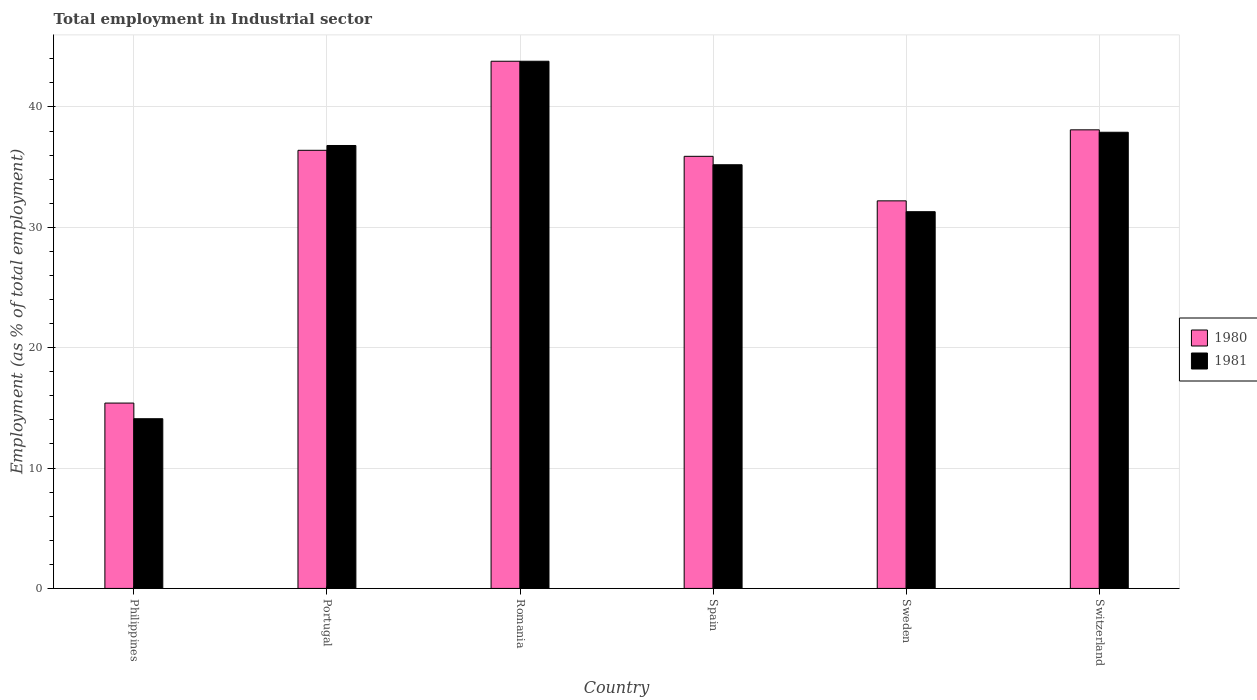How many groups of bars are there?
Offer a terse response. 6. Are the number of bars per tick equal to the number of legend labels?
Ensure brevity in your answer.  Yes. How many bars are there on the 3rd tick from the left?
Offer a terse response. 2. How many bars are there on the 1st tick from the right?
Provide a succinct answer. 2. What is the employment in industrial sector in 1981 in Philippines?
Ensure brevity in your answer.  14.1. Across all countries, what is the maximum employment in industrial sector in 1981?
Provide a succinct answer. 43.8. Across all countries, what is the minimum employment in industrial sector in 1980?
Ensure brevity in your answer.  15.4. In which country was the employment in industrial sector in 1980 maximum?
Ensure brevity in your answer.  Romania. What is the total employment in industrial sector in 1981 in the graph?
Give a very brief answer. 199.1. What is the difference between the employment in industrial sector in 1980 in Philippines and that in Sweden?
Offer a terse response. -16.8. What is the difference between the employment in industrial sector in 1980 in Switzerland and the employment in industrial sector in 1981 in Portugal?
Keep it short and to the point. 1.3. What is the average employment in industrial sector in 1981 per country?
Provide a succinct answer. 33.18. In how many countries, is the employment in industrial sector in 1981 greater than 34 %?
Offer a terse response. 4. What is the ratio of the employment in industrial sector in 1980 in Portugal to that in Switzerland?
Keep it short and to the point. 0.96. Is the employment in industrial sector in 1980 in Romania less than that in Spain?
Your response must be concise. No. Is the difference between the employment in industrial sector in 1980 in Philippines and Spain greater than the difference between the employment in industrial sector in 1981 in Philippines and Spain?
Your answer should be compact. Yes. What is the difference between the highest and the lowest employment in industrial sector in 1981?
Make the answer very short. 29.7. Is the sum of the employment in industrial sector in 1980 in Philippines and Spain greater than the maximum employment in industrial sector in 1981 across all countries?
Provide a succinct answer. Yes. What does the 2nd bar from the left in Philippines represents?
Keep it short and to the point. 1981. What does the 2nd bar from the right in Switzerland represents?
Your answer should be very brief. 1980. Are all the bars in the graph horizontal?
Give a very brief answer. No. What is the difference between two consecutive major ticks on the Y-axis?
Offer a terse response. 10. Are the values on the major ticks of Y-axis written in scientific E-notation?
Your answer should be very brief. No. Does the graph contain any zero values?
Offer a terse response. No. Does the graph contain grids?
Make the answer very short. Yes. Where does the legend appear in the graph?
Your response must be concise. Center right. How many legend labels are there?
Provide a short and direct response. 2. What is the title of the graph?
Offer a very short reply. Total employment in Industrial sector. What is the label or title of the Y-axis?
Make the answer very short. Employment (as % of total employment). What is the Employment (as % of total employment) in 1980 in Philippines?
Keep it short and to the point. 15.4. What is the Employment (as % of total employment) in 1981 in Philippines?
Provide a short and direct response. 14.1. What is the Employment (as % of total employment) in 1980 in Portugal?
Make the answer very short. 36.4. What is the Employment (as % of total employment) in 1981 in Portugal?
Your response must be concise. 36.8. What is the Employment (as % of total employment) in 1980 in Romania?
Offer a very short reply. 43.8. What is the Employment (as % of total employment) of 1981 in Romania?
Make the answer very short. 43.8. What is the Employment (as % of total employment) of 1980 in Spain?
Ensure brevity in your answer.  35.9. What is the Employment (as % of total employment) in 1981 in Spain?
Give a very brief answer. 35.2. What is the Employment (as % of total employment) of 1980 in Sweden?
Offer a very short reply. 32.2. What is the Employment (as % of total employment) of 1981 in Sweden?
Your answer should be compact. 31.3. What is the Employment (as % of total employment) in 1980 in Switzerland?
Keep it short and to the point. 38.1. What is the Employment (as % of total employment) of 1981 in Switzerland?
Your answer should be compact. 37.9. Across all countries, what is the maximum Employment (as % of total employment) in 1980?
Give a very brief answer. 43.8. Across all countries, what is the maximum Employment (as % of total employment) in 1981?
Your answer should be very brief. 43.8. Across all countries, what is the minimum Employment (as % of total employment) in 1980?
Your answer should be very brief. 15.4. Across all countries, what is the minimum Employment (as % of total employment) of 1981?
Provide a succinct answer. 14.1. What is the total Employment (as % of total employment) in 1980 in the graph?
Provide a succinct answer. 201.8. What is the total Employment (as % of total employment) of 1981 in the graph?
Make the answer very short. 199.1. What is the difference between the Employment (as % of total employment) in 1980 in Philippines and that in Portugal?
Provide a short and direct response. -21. What is the difference between the Employment (as % of total employment) of 1981 in Philippines and that in Portugal?
Your response must be concise. -22.7. What is the difference between the Employment (as % of total employment) in 1980 in Philippines and that in Romania?
Make the answer very short. -28.4. What is the difference between the Employment (as % of total employment) of 1981 in Philippines and that in Romania?
Your response must be concise. -29.7. What is the difference between the Employment (as % of total employment) in 1980 in Philippines and that in Spain?
Offer a terse response. -20.5. What is the difference between the Employment (as % of total employment) in 1981 in Philippines and that in Spain?
Give a very brief answer. -21.1. What is the difference between the Employment (as % of total employment) of 1980 in Philippines and that in Sweden?
Your response must be concise. -16.8. What is the difference between the Employment (as % of total employment) of 1981 in Philippines and that in Sweden?
Your answer should be compact. -17.2. What is the difference between the Employment (as % of total employment) of 1980 in Philippines and that in Switzerland?
Keep it short and to the point. -22.7. What is the difference between the Employment (as % of total employment) in 1981 in Philippines and that in Switzerland?
Make the answer very short. -23.8. What is the difference between the Employment (as % of total employment) in 1980 in Portugal and that in Romania?
Provide a short and direct response. -7.4. What is the difference between the Employment (as % of total employment) in 1981 in Portugal and that in Romania?
Offer a terse response. -7. What is the difference between the Employment (as % of total employment) of 1981 in Portugal and that in Sweden?
Keep it short and to the point. 5.5. What is the difference between the Employment (as % of total employment) of 1981 in Portugal and that in Switzerland?
Offer a very short reply. -1.1. What is the difference between the Employment (as % of total employment) in 1980 in Romania and that in Spain?
Offer a very short reply. 7.9. What is the difference between the Employment (as % of total employment) in 1981 in Romania and that in Spain?
Your answer should be very brief. 8.6. What is the difference between the Employment (as % of total employment) in 1981 in Romania and that in Sweden?
Offer a terse response. 12.5. What is the difference between the Employment (as % of total employment) of 1980 in Spain and that in Sweden?
Provide a succinct answer. 3.7. What is the difference between the Employment (as % of total employment) in 1981 in Spain and that in Sweden?
Give a very brief answer. 3.9. What is the difference between the Employment (as % of total employment) in 1980 in Spain and that in Switzerland?
Your response must be concise. -2.2. What is the difference between the Employment (as % of total employment) in 1981 in Spain and that in Switzerland?
Make the answer very short. -2.7. What is the difference between the Employment (as % of total employment) in 1980 in Sweden and that in Switzerland?
Your answer should be compact. -5.9. What is the difference between the Employment (as % of total employment) in 1980 in Philippines and the Employment (as % of total employment) in 1981 in Portugal?
Ensure brevity in your answer.  -21.4. What is the difference between the Employment (as % of total employment) of 1980 in Philippines and the Employment (as % of total employment) of 1981 in Romania?
Your answer should be very brief. -28.4. What is the difference between the Employment (as % of total employment) of 1980 in Philippines and the Employment (as % of total employment) of 1981 in Spain?
Provide a succinct answer. -19.8. What is the difference between the Employment (as % of total employment) of 1980 in Philippines and the Employment (as % of total employment) of 1981 in Sweden?
Ensure brevity in your answer.  -15.9. What is the difference between the Employment (as % of total employment) in 1980 in Philippines and the Employment (as % of total employment) in 1981 in Switzerland?
Offer a very short reply. -22.5. What is the difference between the Employment (as % of total employment) in 1980 in Portugal and the Employment (as % of total employment) in 1981 in Romania?
Offer a terse response. -7.4. What is the difference between the Employment (as % of total employment) in 1980 in Romania and the Employment (as % of total employment) in 1981 in Spain?
Make the answer very short. 8.6. What is the difference between the Employment (as % of total employment) in 1980 in Romania and the Employment (as % of total employment) in 1981 in Switzerland?
Offer a terse response. 5.9. What is the difference between the Employment (as % of total employment) of 1980 in Spain and the Employment (as % of total employment) of 1981 in Sweden?
Make the answer very short. 4.6. What is the difference between the Employment (as % of total employment) of 1980 in Sweden and the Employment (as % of total employment) of 1981 in Switzerland?
Provide a succinct answer. -5.7. What is the average Employment (as % of total employment) of 1980 per country?
Provide a short and direct response. 33.63. What is the average Employment (as % of total employment) in 1981 per country?
Ensure brevity in your answer.  33.18. What is the difference between the Employment (as % of total employment) in 1980 and Employment (as % of total employment) in 1981 in Philippines?
Your answer should be compact. 1.3. What is the difference between the Employment (as % of total employment) of 1980 and Employment (as % of total employment) of 1981 in Portugal?
Make the answer very short. -0.4. What is the difference between the Employment (as % of total employment) of 1980 and Employment (as % of total employment) of 1981 in Romania?
Make the answer very short. 0. What is the ratio of the Employment (as % of total employment) of 1980 in Philippines to that in Portugal?
Make the answer very short. 0.42. What is the ratio of the Employment (as % of total employment) in 1981 in Philippines to that in Portugal?
Your answer should be very brief. 0.38. What is the ratio of the Employment (as % of total employment) in 1980 in Philippines to that in Romania?
Provide a short and direct response. 0.35. What is the ratio of the Employment (as % of total employment) in 1981 in Philippines to that in Romania?
Provide a short and direct response. 0.32. What is the ratio of the Employment (as % of total employment) of 1980 in Philippines to that in Spain?
Make the answer very short. 0.43. What is the ratio of the Employment (as % of total employment) in 1981 in Philippines to that in Spain?
Your response must be concise. 0.4. What is the ratio of the Employment (as % of total employment) of 1980 in Philippines to that in Sweden?
Provide a succinct answer. 0.48. What is the ratio of the Employment (as % of total employment) of 1981 in Philippines to that in Sweden?
Your answer should be very brief. 0.45. What is the ratio of the Employment (as % of total employment) of 1980 in Philippines to that in Switzerland?
Offer a terse response. 0.4. What is the ratio of the Employment (as % of total employment) of 1981 in Philippines to that in Switzerland?
Offer a very short reply. 0.37. What is the ratio of the Employment (as % of total employment) in 1980 in Portugal to that in Romania?
Offer a very short reply. 0.83. What is the ratio of the Employment (as % of total employment) of 1981 in Portugal to that in Romania?
Ensure brevity in your answer.  0.84. What is the ratio of the Employment (as % of total employment) of 1980 in Portugal to that in Spain?
Offer a very short reply. 1.01. What is the ratio of the Employment (as % of total employment) of 1981 in Portugal to that in Spain?
Give a very brief answer. 1.05. What is the ratio of the Employment (as % of total employment) in 1980 in Portugal to that in Sweden?
Offer a very short reply. 1.13. What is the ratio of the Employment (as % of total employment) of 1981 in Portugal to that in Sweden?
Offer a very short reply. 1.18. What is the ratio of the Employment (as % of total employment) in 1980 in Portugal to that in Switzerland?
Ensure brevity in your answer.  0.96. What is the ratio of the Employment (as % of total employment) in 1981 in Portugal to that in Switzerland?
Your response must be concise. 0.97. What is the ratio of the Employment (as % of total employment) in 1980 in Romania to that in Spain?
Provide a succinct answer. 1.22. What is the ratio of the Employment (as % of total employment) in 1981 in Romania to that in Spain?
Your answer should be compact. 1.24. What is the ratio of the Employment (as % of total employment) in 1980 in Romania to that in Sweden?
Your answer should be compact. 1.36. What is the ratio of the Employment (as % of total employment) in 1981 in Romania to that in Sweden?
Your answer should be compact. 1.4. What is the ratio of the Employment (as % of total employment) in 1980 in Romania to that in Switzerland?
Keep it short and to the point. 1.15. What is the ratio of the Employment (as % of total employment) in 1981 in Romania to that in Switzerland?
Give a very brief answer. 1.16. What is the ratio of the Employment (as % of total employment) in 1980 in Spain to that in Sweden?
Give a very brief answer. 1.11. What is the ratio of the Employment (as % of total employment) of 1981 in Spain to that in Sweden?
Offer a very short reply. 1.12. What is the ratio of the Employment (as % of total employment) of 1980 in Spain to that in Switzerland?
Offer a very short reply. 0.94. What is the ratio of the Employment (as % of total employment) in 1981 in Spain to that in Switzerland?
Provide a succinct answer. 0.93. What is the ratio of the Employment (as % of total employment) in 1980 in Sweden to that in Switzerland?
Offer a terse response. 0.85. What is the ratio of the Employment (as % of total employment) in 1981 in Sweden to that in Switzerland?
Your response must be concise. 0.83. What is the difference between the highest and the second highest Employment (as % of total employment) in 1980?
Your answer should be compact. 5.7. What is the difference between the highest and the second highest Employment (as % of total employment) in 1981?
Provide a succinct answer. 5.9. What is the difference between the highest and the lowest Employment (as % of total employment) in 1980?
Offer a very short reply. 28.4. What is the difference between the highest and the lowest Employment (as % of total employment) of 1981?
Provide a succinct answer. 29.7. 